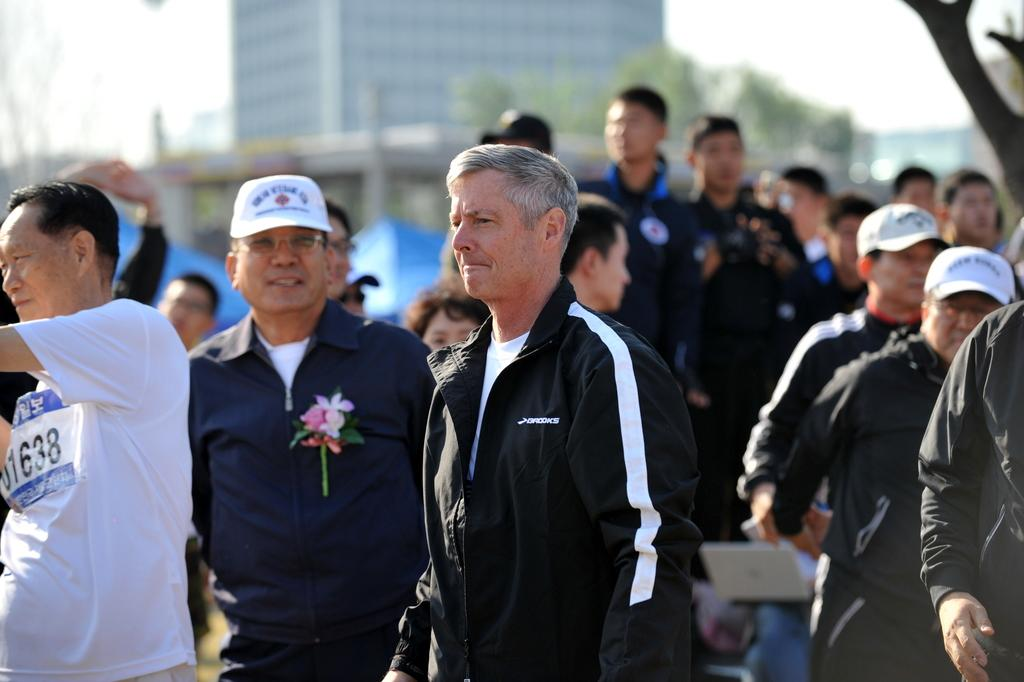How many people are in the image? There is a group of people standing in the image, but the exact number cannot be determined from the provided facts. What can be seen in the background of the image? There are trees and a building in the background of the image. What type of thrill can be experienced by the people in the image? There is no information about any thrilling activity or experience in the image. 